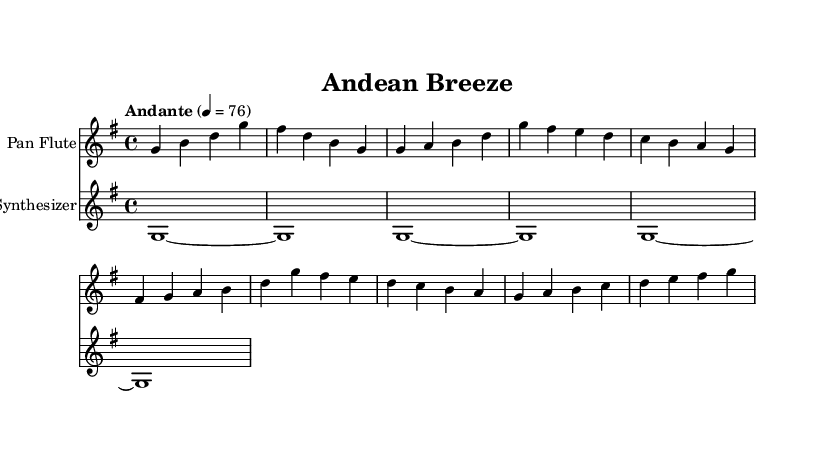What is the key signature of this music? The key signature is G major, which has one sharp (F#). This is visible in the beginning of the piece where the G major key is indicated.
Answer: G major What is the time signature used in this music? The time signature displayed at the beginning is 4/4, which indicates that there are four beats in a measure and the quarter note gets one beat.
Answer: 4/4 What is the tempo marking for this piece? The tempo marking states "Andante" with a metronome marking of 76, indicating a moderately slow tempo. This can be found at the beginning of the score.
Answer: Andante What instruments are featured in this score? The score includes two instruments: the Pan Flute and the Synthesizer, as indicated in the staff names.
Answer: Pan Flute, Synthesizer How many measures are there in the verse section? The verse section consists of two measures, which can be counted from the notation following the introductory measures. Each section of the music clearly delineates the start and end of phrases.
Answer: 2 What kind of sound does the synthesizer produce in this piece? The synthesizer is specified to use "pad 2 (warm)" as the sound setting. This is noted in the staff's instrument settings and signifies a warm, ambient sound typically used for background textures.
Answer: pad 2 (warm) What melodic movement does the pan flute primarily utilize in the chorus? In the chorus, the pan flute primarily utilizes ascending melodic movement, progressing in pitch from lower to higher notes. This is observed as it moves from lower notes like d and c to higher notes like e and g.
Answer: Ascending 